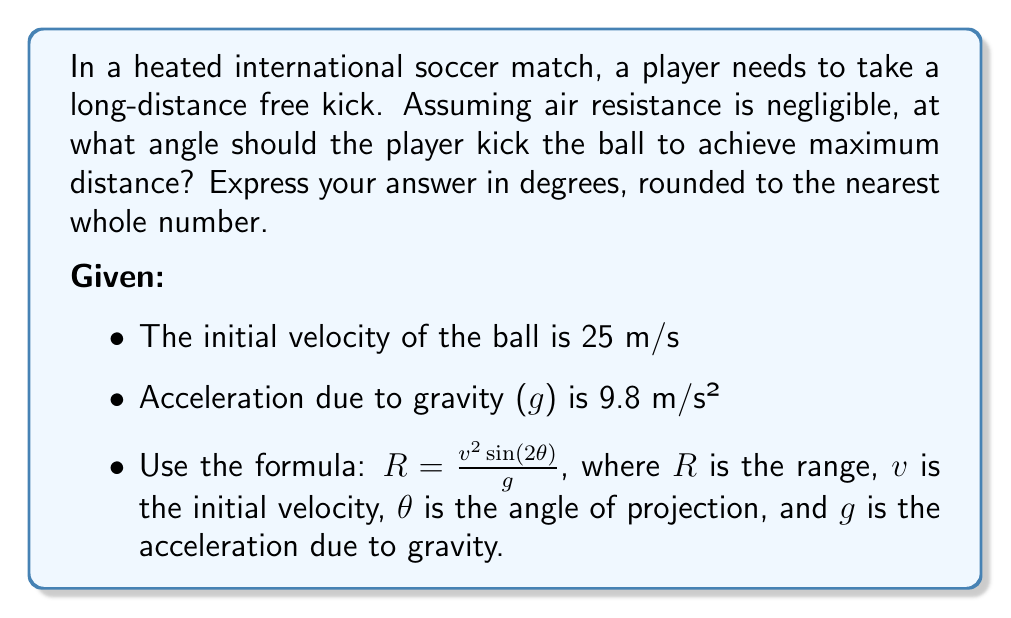Show me your answer to this math problem. To find the optimal angle for maximum distance, we need to maximize the range equation:

$$R = \frac{v^2 \sin(2\theta)}{g}$$

The range R is maximum when $\sin(2\theta)$ is maximum. We know that the sine function reaches its maximum value of 1 when its argument is 90°.

Therefore:

$$2\theta = 90°$$
$$\theta = 45°$$

To verify this mathematically:

1) Take the derivative of R with respect to θ:

   $$\frac{dR}{d\theta} = \frac{v^2}{g} \cdot 2\cos(2\theta)$$

2) Set this equal to zero to find the critical point:

   $$\frac{v^2}{g} \cdot 2\cos(2\theta) = 0$$
   $$\cos(2\theta) = 0$$

3) Solve for θ:

   $$2\theta = 90°$$ (because cosine is zero at 90°)
   $$\theta = 45°$$

4) The second derivative is negative at θ = 45°, confirming this is a maximum.

Therefore, the optimal angle to kick the ball for maximum distance is 45°.

Note: This result is independent of the initial velocity and the acceleration due to gravity, making it applicable in various sports and scenarios where projectile motion is involved.
Answer: 45° 